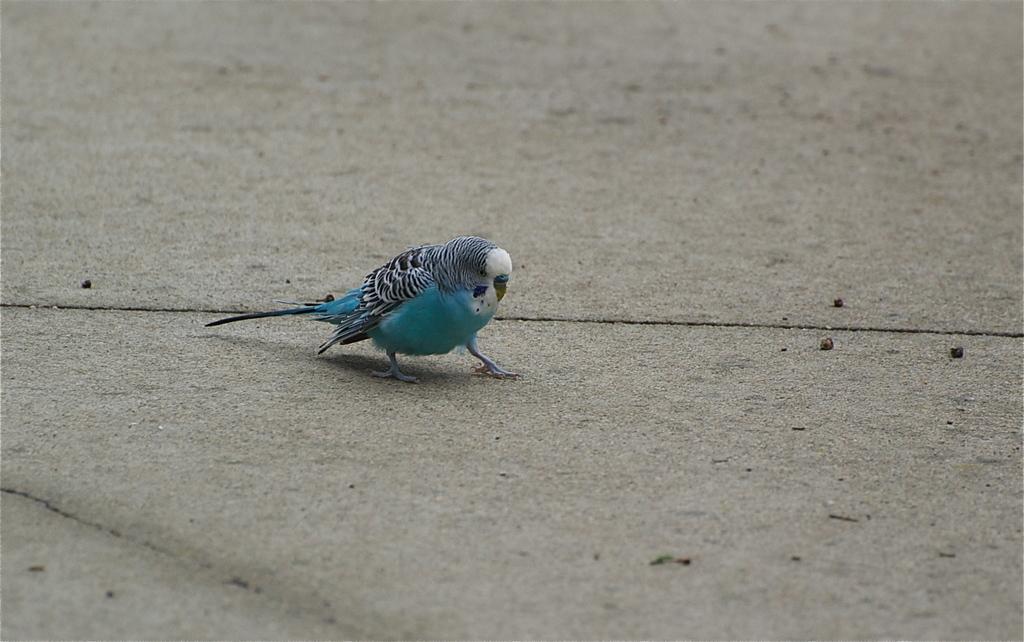Please provide a concise description of this image. It is a parrot in blue color. 